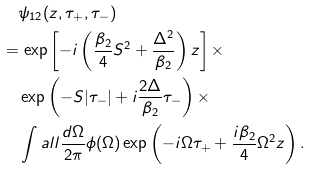Convert formula to latex. <formula><loc_0><loc_0><loc_500><loc_500>& \quad \psi _ { 1 2 } ( z , \tau _ { + } , \tau _ { - } ) \\ & = \exp \left [ - i \left ( \frac { \beta _ { 2 } } { 4 } S ^ { 2 } + \frac { \Delta ^ { 2 } } { \beta _ { 2 } } \right ) z \right ] \times \\ & \quad \exp \left ( - S | \tau _ { - } | + i \frac { 2 \Delta } { \beta _ { 2 } } \tau _ { - } \right ) \times \\ & \quad \int a l l \frac { d \Omega } { 2 \pi } \phi ( \Omega ) \exp \left ( - i \Omega \tau _ { + } + \frac { i \beta _ { 2 } } { 4 } \Omega ^ { 2 } z \right ) .</formula> 